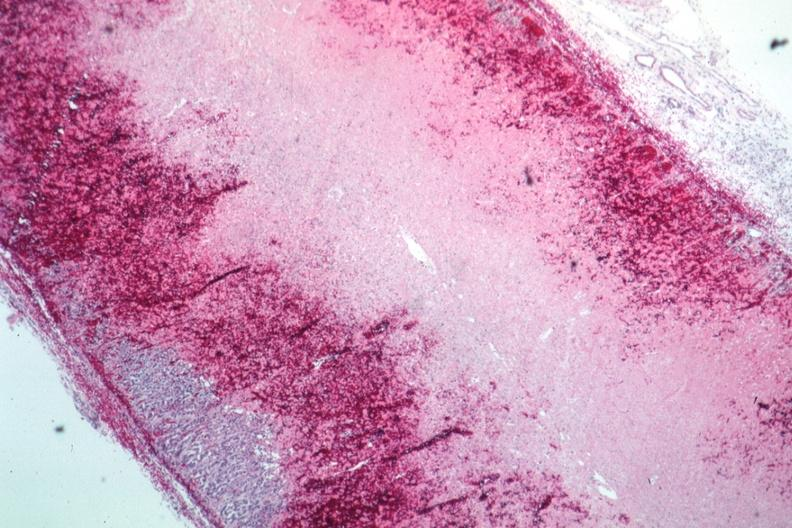what is present?
Answer the question using a single word or phrase. Adrenal 